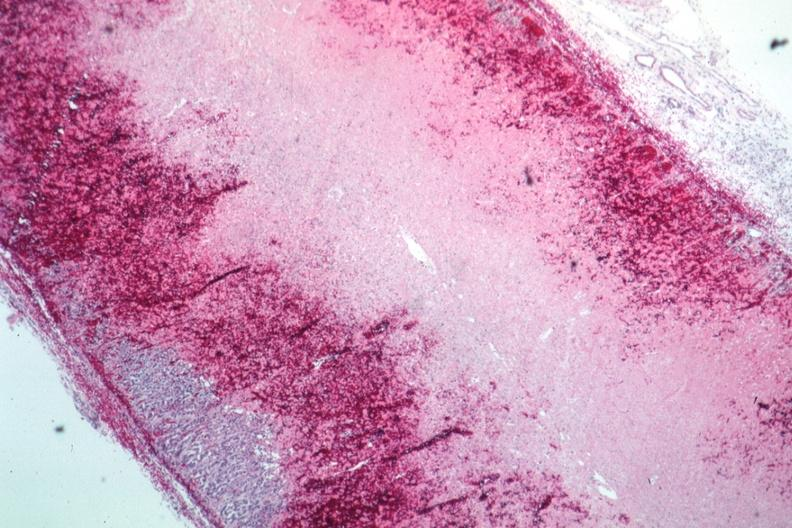what is present?
Answer the question using a single word or phrase. Adrenal 